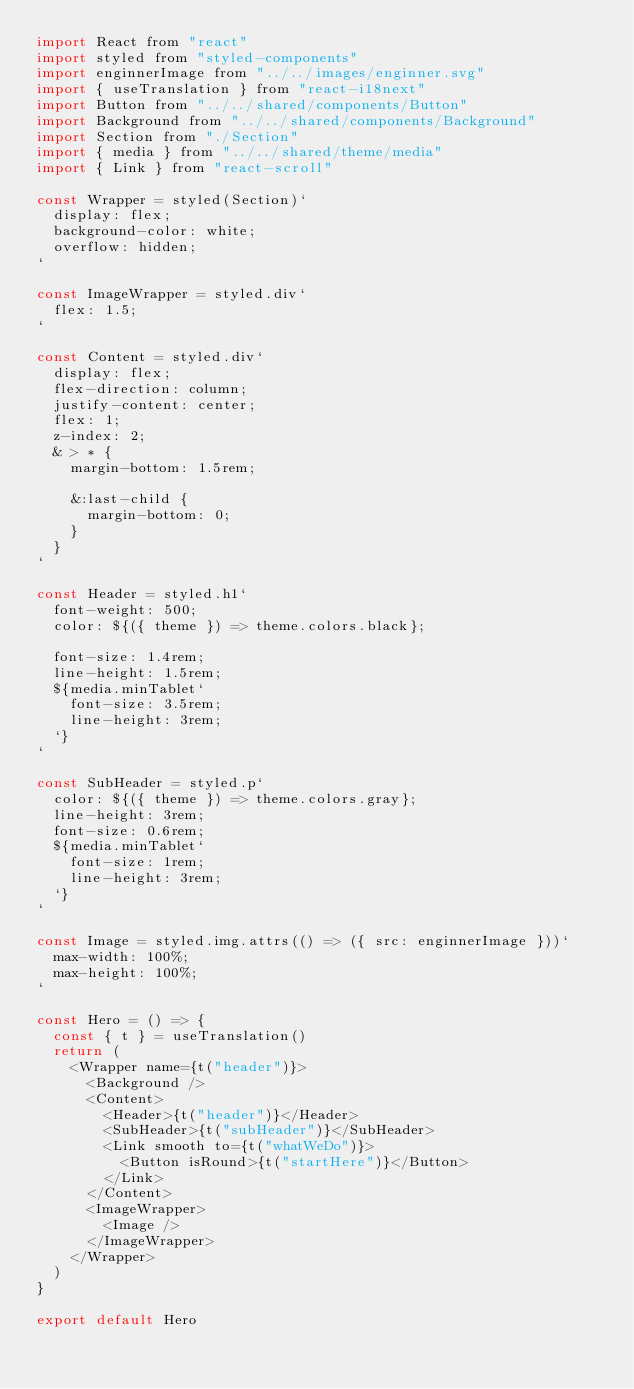<code> <loc_0><loc_0><loc_500><loc_500><_JavaScript_>import React from "react"
import styled from "styled-components"
import enginnerImage from "../../images/enginner.svg"
import { useTranslation } from "react-i18next"
import Button from "../../shared/components/Button"
import Background from "../../shared/components/Background"
import Section from "./Section"
import { media } from "../../shared/theme/media"
import { Link } from "react-scroll"

const Wrapper = styled(Section)`
  display: flex;
  background-color: white;
  overflow: hidden;
`

const ImageWrapper = styled.div`
  flex: 1.5;
`

const Content = styled.div`
  display: flex;
  flex-direction: column;
  justify-content: center;
  flex: 1;
  z-index: 2;
  & > * {
    margin-bottom: 1.5rem;

    &:last-child {
      margin-bottom: 0;
    }
  }
`

const Header = styled.h1`
  font-weight: 500;
  color: ${({ theme }) => theme.colors.black};

  font-size: 1.4rem;
  line-height: 1.5rem;
  ${media.minTablet`
    font-size: 3.5rem;
    line-height: 3rem;
  `}
`

const SubHeader = styled.p`
  color: ${({ theme }) => theme.colors.gray};
  line-height: 3rem;
  font-size: 0.6rem;
  ${media.minTablet`
    font-size: 1rem;
    line-height: 3rem;
  `}
`

const Image = styled.img.attrs(() => ({ src: enginnerImage }))`
  max-width: 100%;
  max-height: 100%;
`

const Hero = () => {
  const { t } = useTranslation()
  return (
    <Wrapper name={t("header")}>
      <Background />
      <Content>
        <Header>{t("header")}</Header>
        <SubHeader>{t("subHeader")}</SubHeader>
        <Link smooth to={t("whatWeDo")}>
          <Button isRound>{t("startHere")}</Button>
        </Link>
      </Content>
      <ImageWrapper>
        <Image />
      </ImageWrapper>
    </Wrapper>
  )
}

export default Hero
</code> 